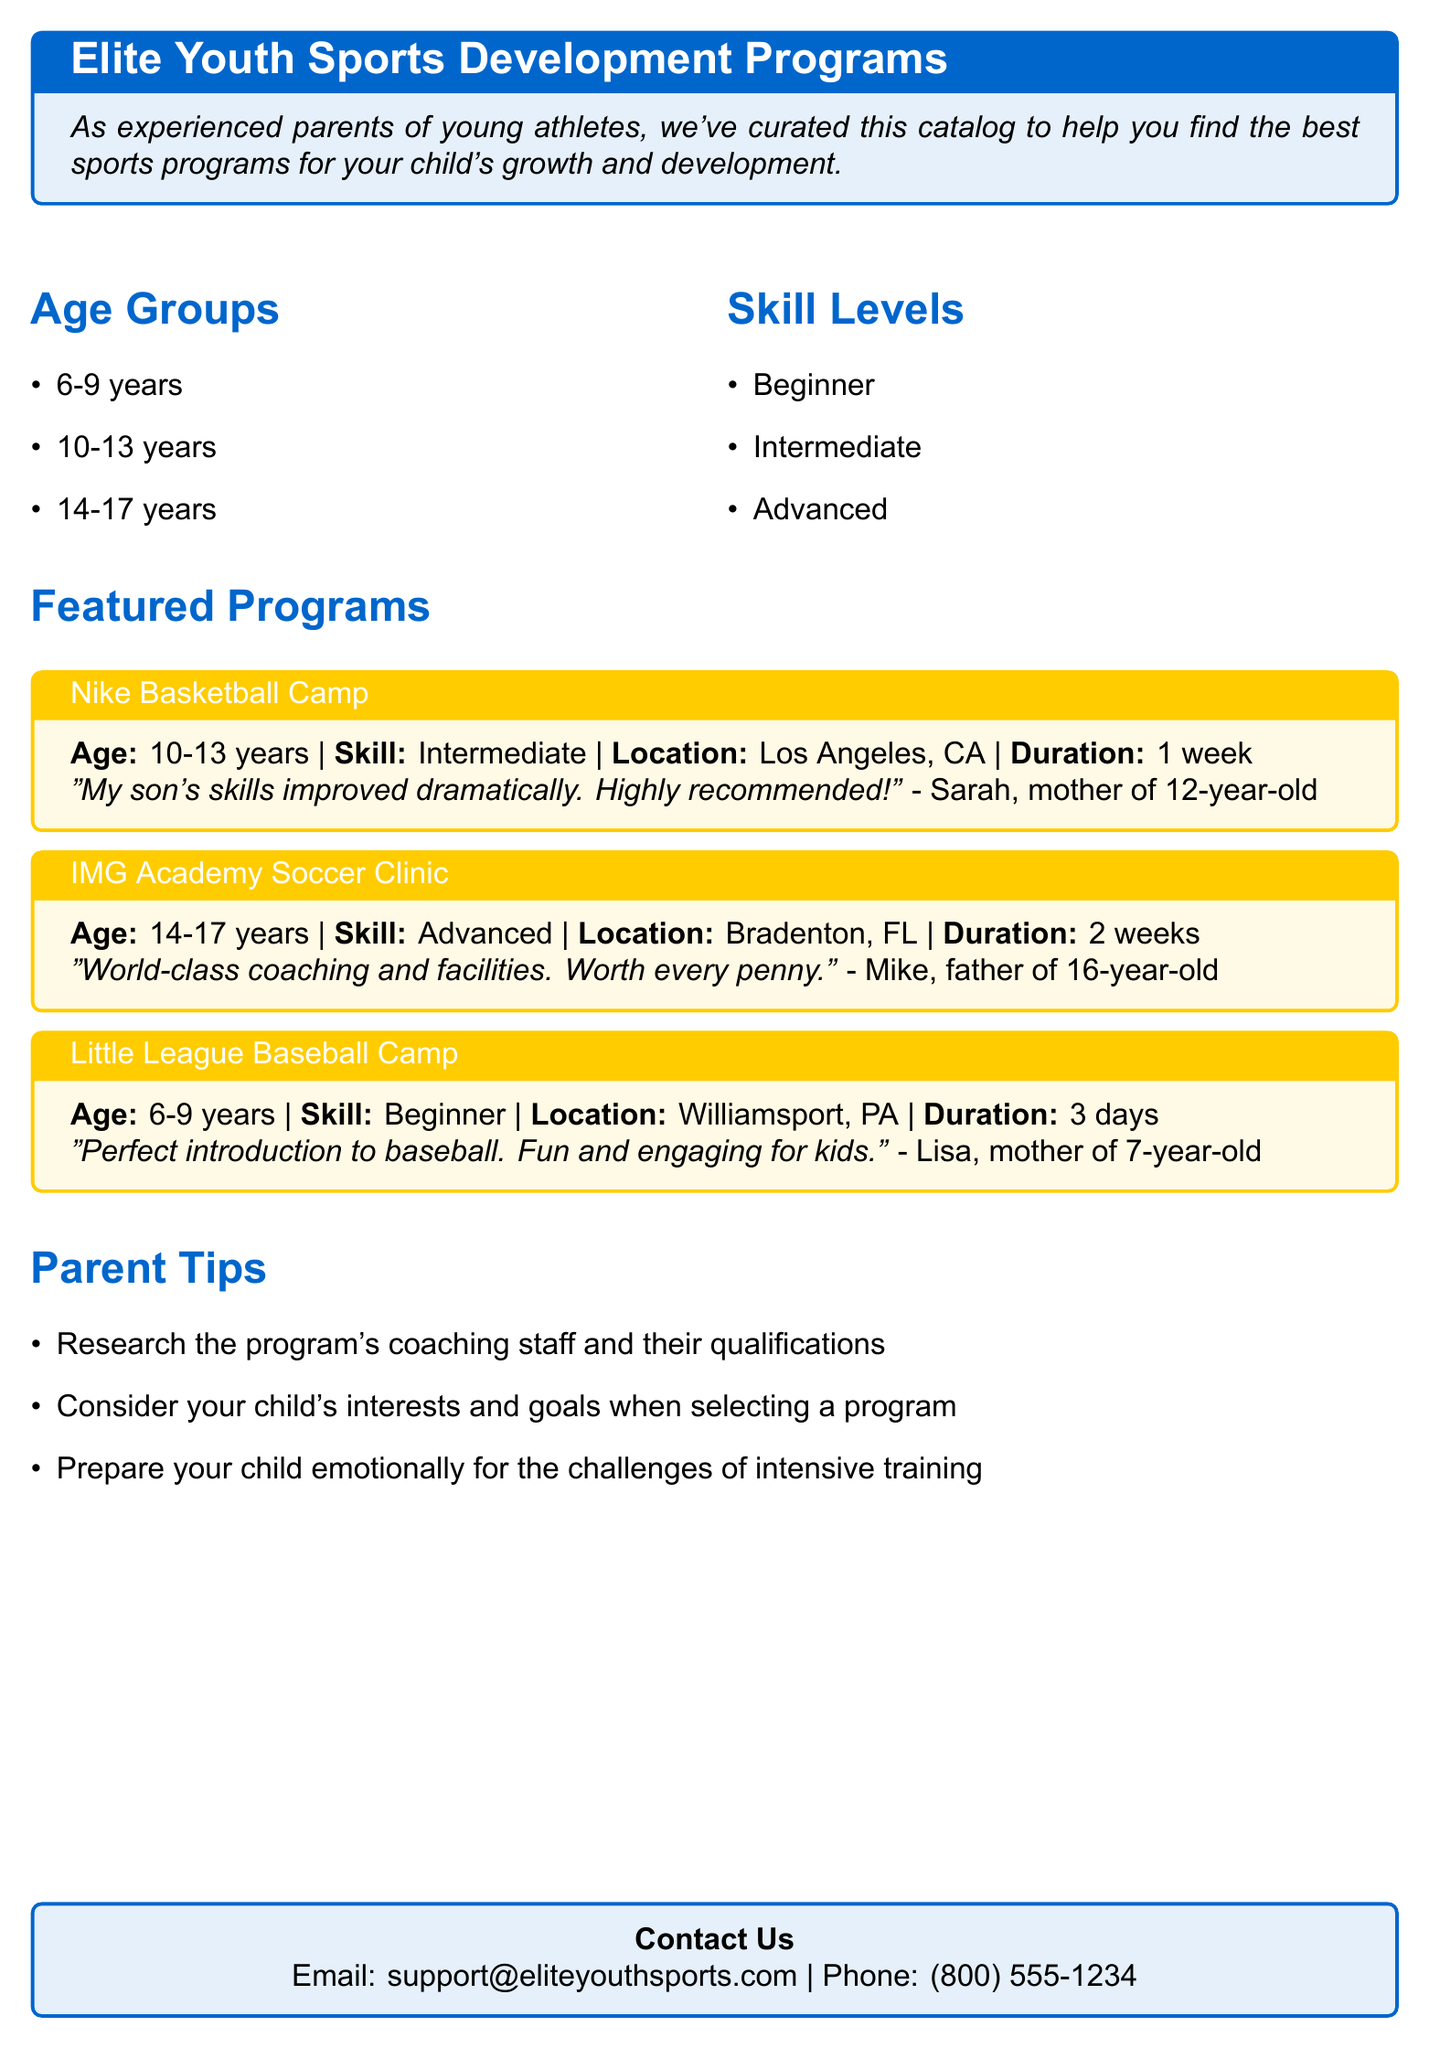What age group is the Nike Basketball Camp for? The Nike Basketball Camp is for the age group of 10-13 years, as stated in the featured programs section.
Answer: 10-13 years What is the skill level for the IMG Academy Soccer Clinic? The skill level for the IMG Academy Soccer Clinic is advanced, as indicated in the details of the program.
Answer: Advanced How long does the Little League Baseball Camp last? The document specifies that the Little League Baseball Camp lasts for 3 days.
Answer: 3 days What can parents consider when selecting a program for their child? Parents can consider their child's interests and goals when selecting a program, as mentioned in the parent tips section.
Answer: Child's interests and goals Who recommended the Nike Basketball Camp? The Nike Basketball Camp was recommended by Sarah, the mother of a 12-year-old, according to the review provided.
Answer: Sarah What is the location of the IMG Academy Soccer Clinic? The location of the IMG Academy Soccer Clinic is Bradenton, FL, as noted in the program details.
Answer: Bradenton, FL What is one tip given to parents in the document? One tip given to parents is to research the program's coaching staff and their qualifications, as listed in the parent tips.
Answer: Research coaching staff What type of document is this? This document is a catalog, as indicated by the title and introductory text.
Answer: Catalog What does the document emphasize for young athletes' development? The document emphasizes finding the best sports programs for children's growth and development throughout its text.
Answer: Growth and development 